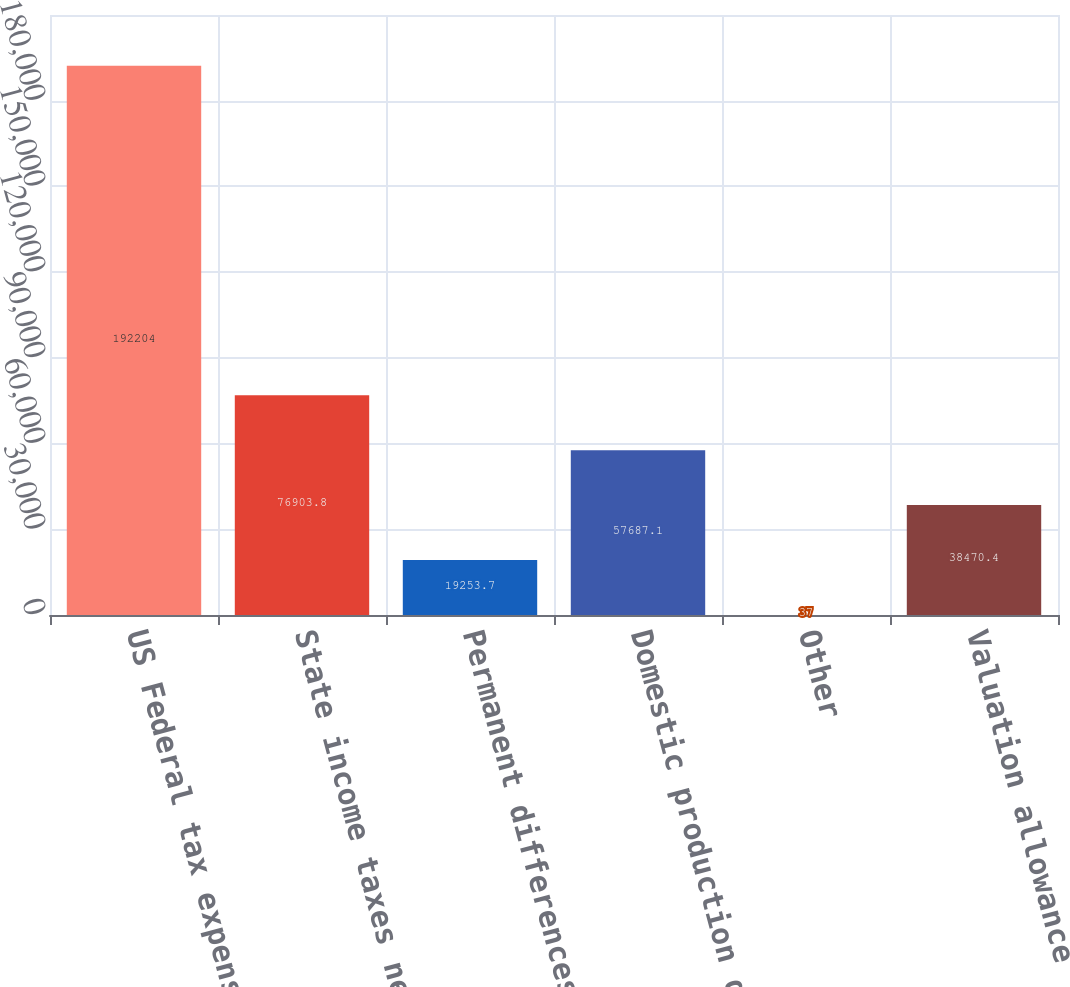<chart> <loc_0><loc_0><loc_500><loc_500><bar_chart><fcel>US Federal tax expense at<fcel>State income taxes net of<fcel>Permanent differences<fcel>Domestic production deduction<fcel>Other<fcel>Valuation allowance<nl><fcel>192204<fcel>76903.8<fcel>19253.7<fcel>57687.1<fcel>37<fcel>38470.4<nl></chart> 